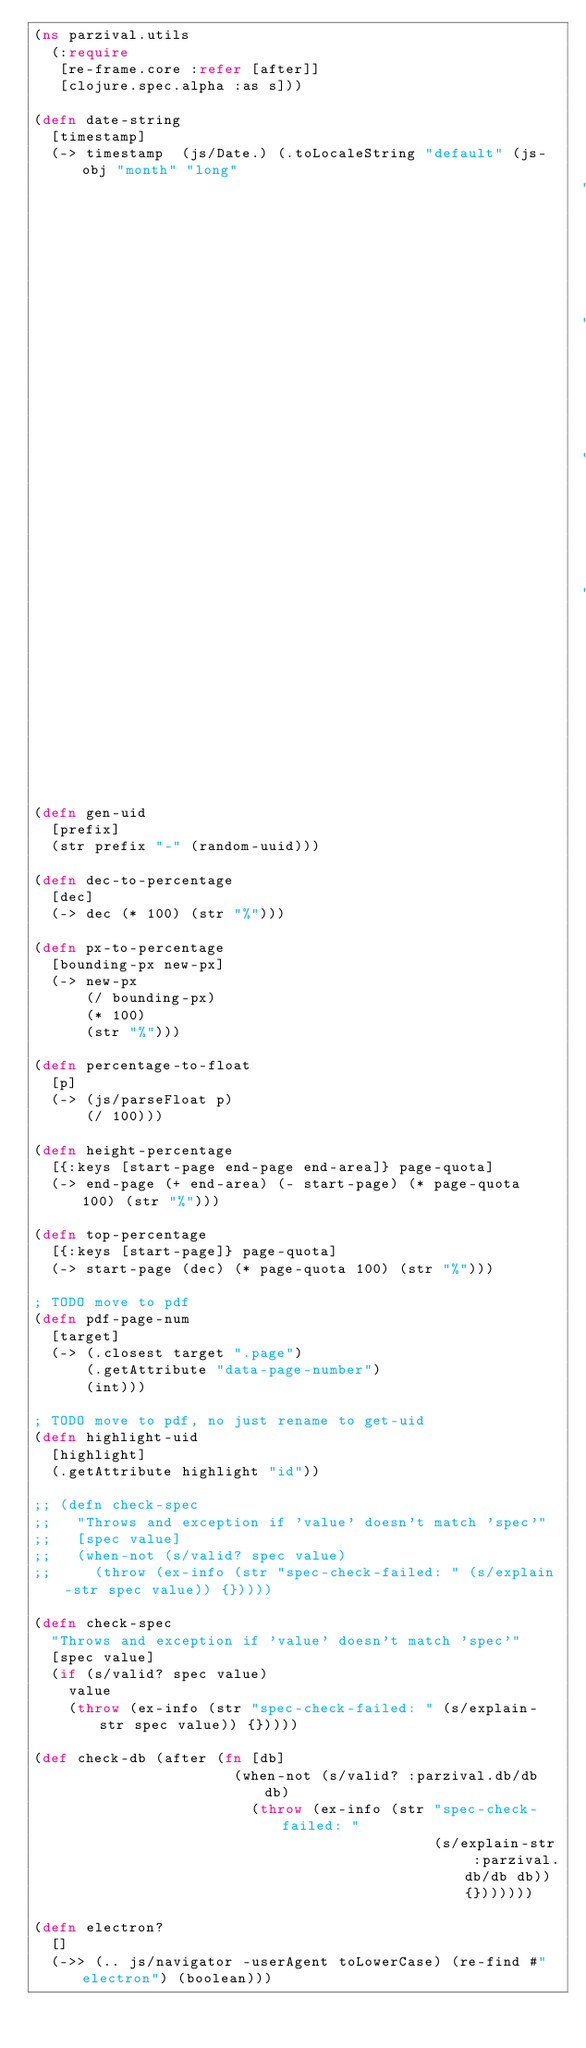<code> <loc_0><loc_0><loc_500><loc_500><_Clojure_>(ns parzival.utils
  (:require
   [re-frame.core :refer [after]] 
   [clojure.spec.alpha :as s]))

(defn date-string
  [timestamp]
  (-> timestamp  (js/Date.) (.toLocaleString "default" (js-obj "month" "long"
                                                               "day" "numeric"
                                                               "year" "numeric"
                                                               "hour" "numeric"
                                                               "minute" "numeric"))))

(defn gen-uid
  [prefix]
  (str prefix "-" (random-uuid)))

(defn dec-to-percentage
  [dec]
  (-> dec (* 100) (str "%")))

(defn px-to-percentage
  [bounding-px new-px]
  (-> new-px
      (/ bounding-px)
      (* 100)
      (str "%")))

(defn percentage-to-float
  [p]
  (-> (js/parseFloat p)
      (/ 100)))

(defn height-percentage
  [{:keys [start-page end-page end-area]} page-quota]
  (-> end-page (+ end-area) (- start-page) (* page-quota 100) (str "%")))

(defn top-percentage
  [{:keys [start-page]} page-quota]
  (-> start-page (dec) (* page-quota 100) (str "%")))

; TODO move to pdf
(defn pdf-page-num
  [target]
  (-> (.closest target ".page")
      (.getAttribute "data-page-number")
      (int)))

; TODO move to pdf, no just rename to get-uid
(defn highlight-uid
  [highlight]
  (.getAttribute highlight "id"))

;; (defn check-spec
;;   "Throws and exception if 'value' doesn't match 'spec'"
;;   [spec value]
;;   (when-not (s/valid? spec value)
;;     (throw (ex-info (str "spec-check-failed: " (s/explain-str spec value)) {}))))

(defn check-spec
  "Throws and exception if 'value' doesn't match 'spec'"
  [spec value]
  (if (s/valid? spec value)
    value
    (throw (ex-info (str "spec-check-failed: " (s/explain-str spec value)) {}))))

(def check-db (after (fn [db]
                       (when-not (s/valid? :parzival.db/db db)
                         (throw (ex-info (str "spec-check-failed: "
                                              (s/explain-str :parzival.db/db db)) {}))))))

(defn electron?
  []
  (->> (.. js/navigator -userAgent toLowerCase) (re-find #"electron") (boolean)))</code> 